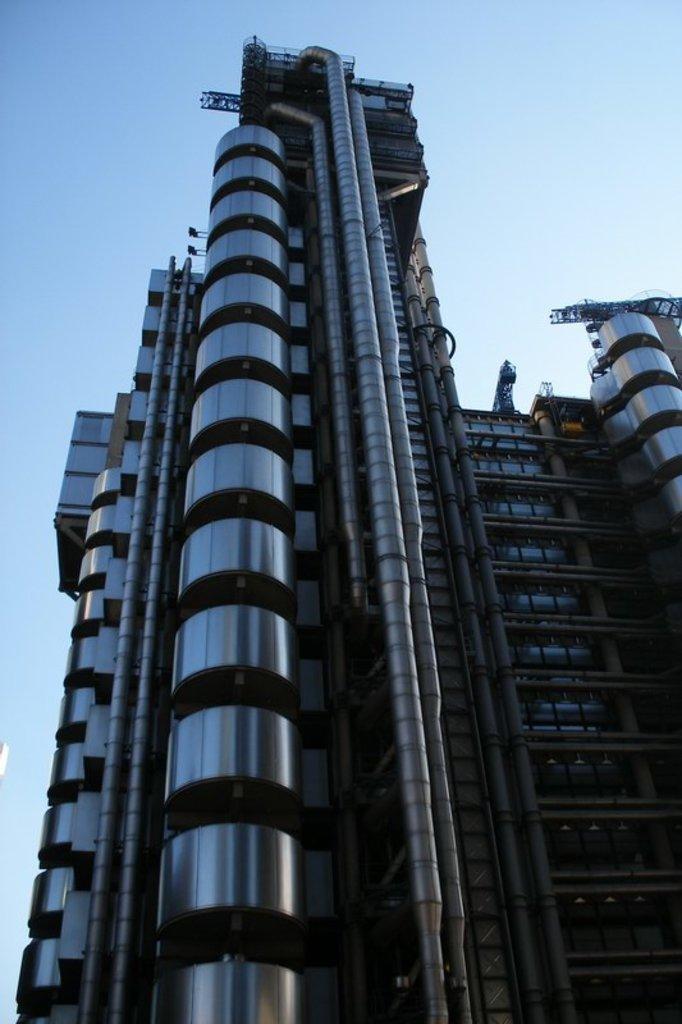How would you summarize this image in a sentence or two? In the picture I can see the tower building and I can see the ventilation pipes on the wall of the building. There are clouds in the sky. 